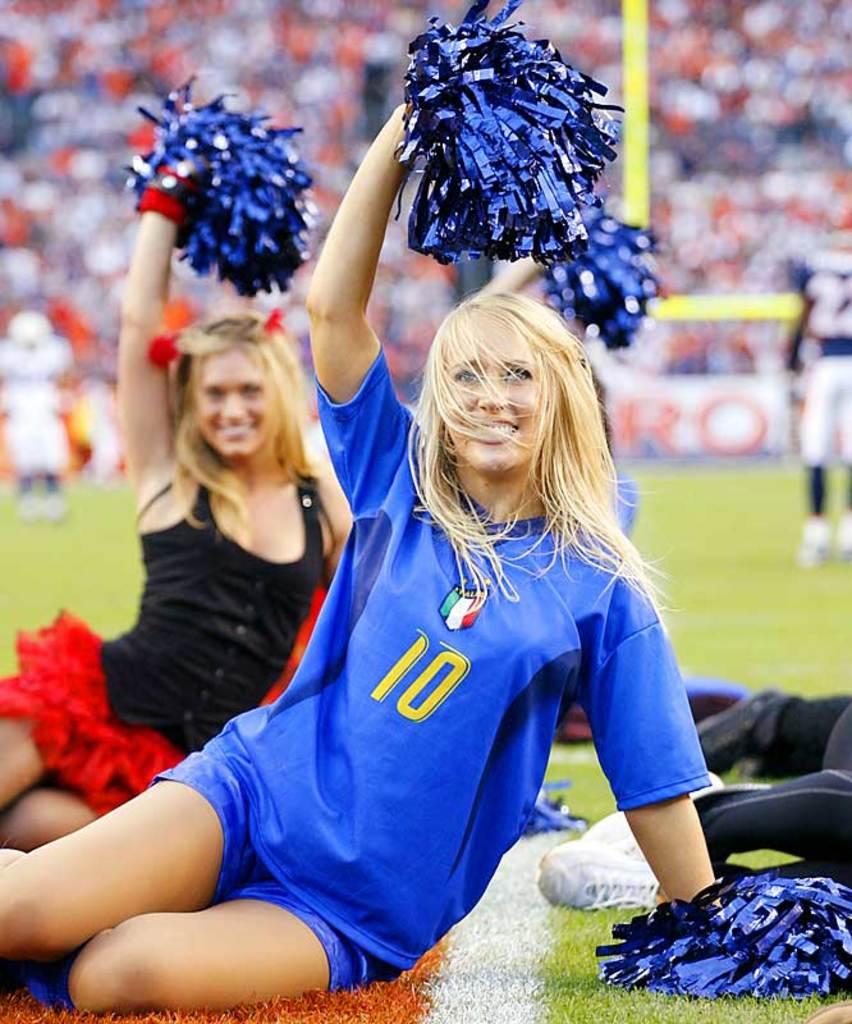Number is 10?
Your answer should be compact. Yes. 